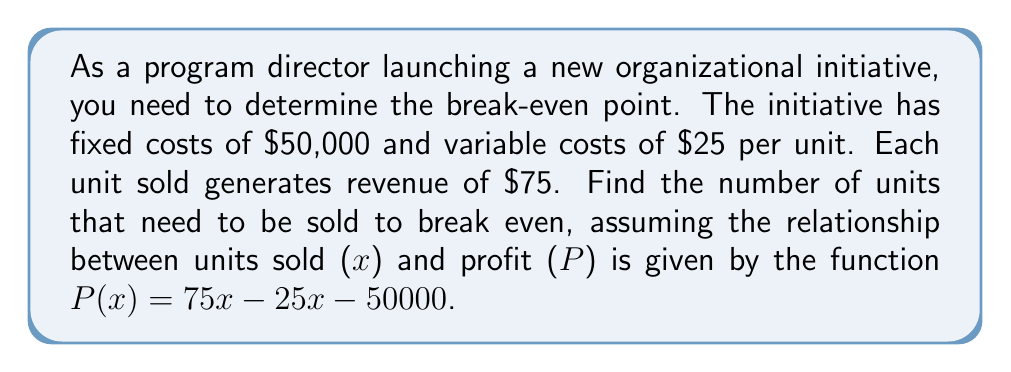Show me your answer to this math problem. To find the break-even point, we need to determine the number of units (x) where the profit (P) equals zero. Let's solve this step-by-step:

1. Start with the profit function:
   $P(x) = 75x - 25x - 50000$

2. Simplify the function:
   $P(x) = 50x - 50000$

3. Set the profit to zero to find the break-even point:
   $0 = 50x - 50000$

4. Add 50000 to both sides:
   $50000 = 50x$

5. Divide both sides by 50:
   $\frac{50000}{50} = x$

6. Simplify:
   $1000 = x$

Therefore, the organization needs to sell 1000 units to break even.

To verify, we can substitute x = 1000 into the original profit function:

$P(1000) = 75(1000) - 25(1000) - 50000$
$= 75000 - 25000 - 50000$
$= 0$

This confirms that at 1000 units, the profit is zero, which is the break-even point.
Answer: 1000 units 